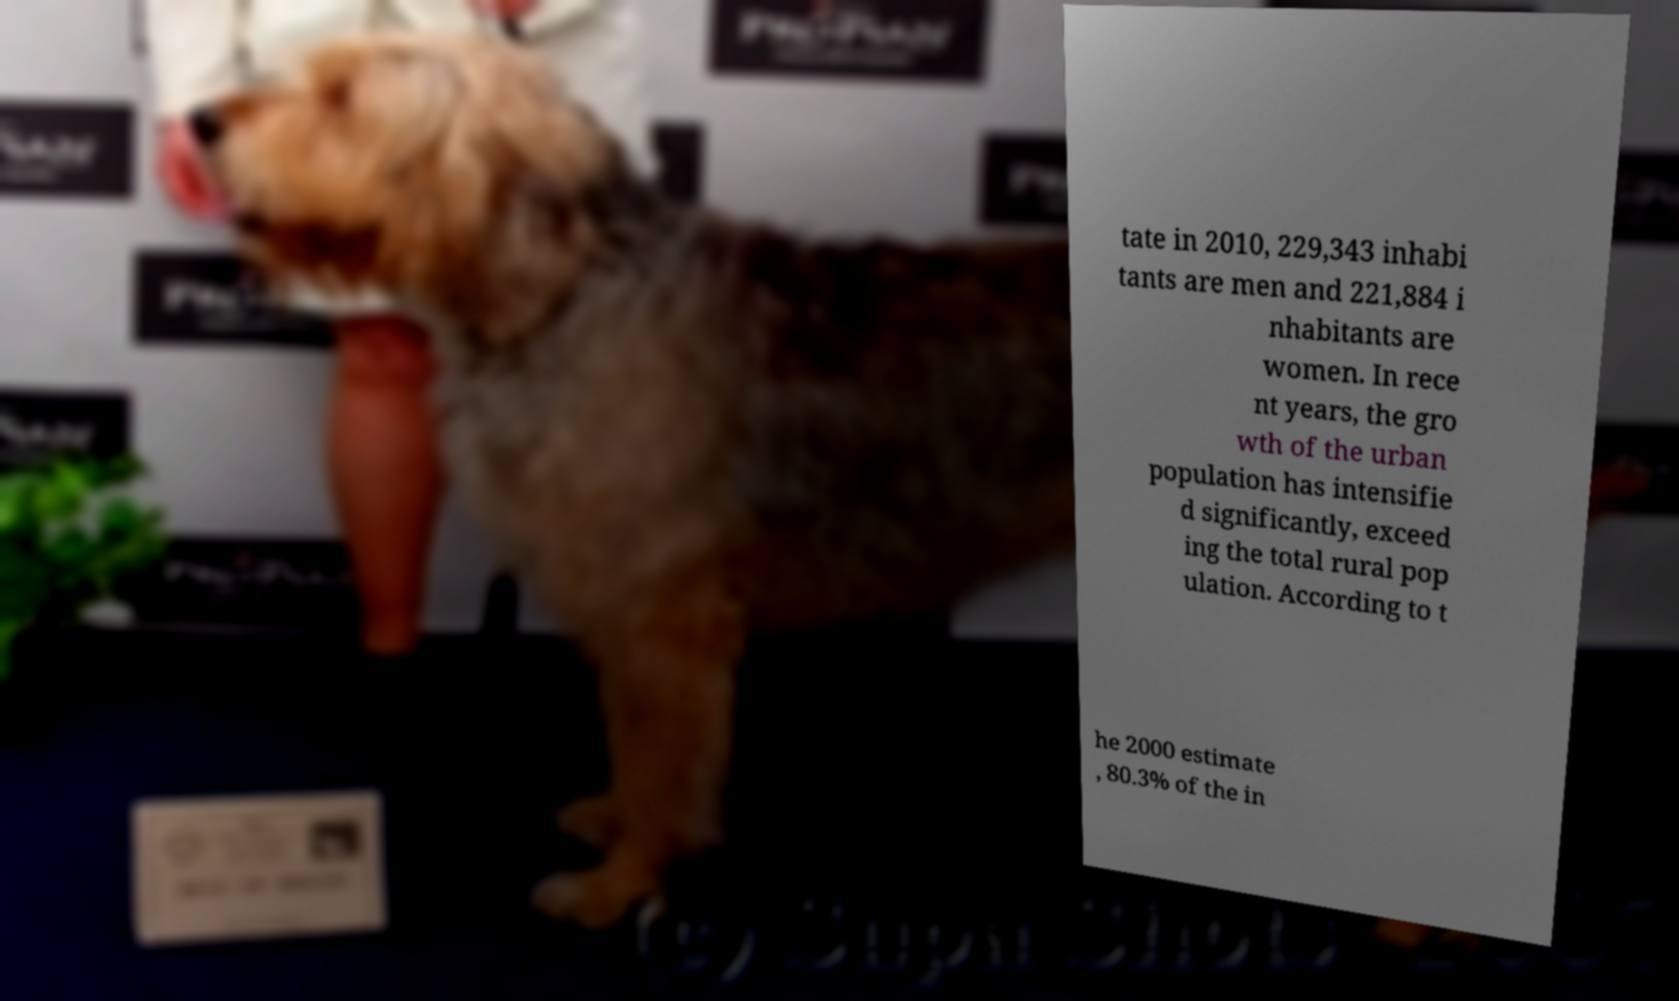For documentation purposes, I need the text within this image transcribed. Could you provide that? tate in 2010, 229,343 inhabi tants are men and 221,884 i nhabitants are women. In rece nt years, the gro wth of the urban population has intensifie d significantly, exceed ing the total rural pop ulation. According to t he 2000 estimate , 80.3% of the in 